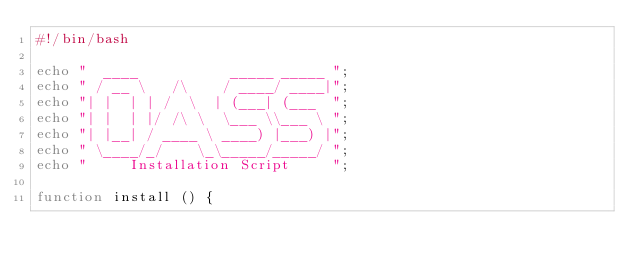Convert code to text. <code><loc_0><loc_0><loc_500><loc_500><_Bash_>#!/bin/bash

echo "  ____           _____ _____ ";
echo " / __ \   /\    / ____/ ____|";
echo "| |  | | /  \  | (___| (___  ";
echo "| |  | |/ /\ \  \___ \\___ \ ";
echo "| |__| / ____ \ ____) |___) |";
echo " \____/_/    \_\_____/_____/ ";
echo "     Installation Script     ";                           

function install () {</code> 